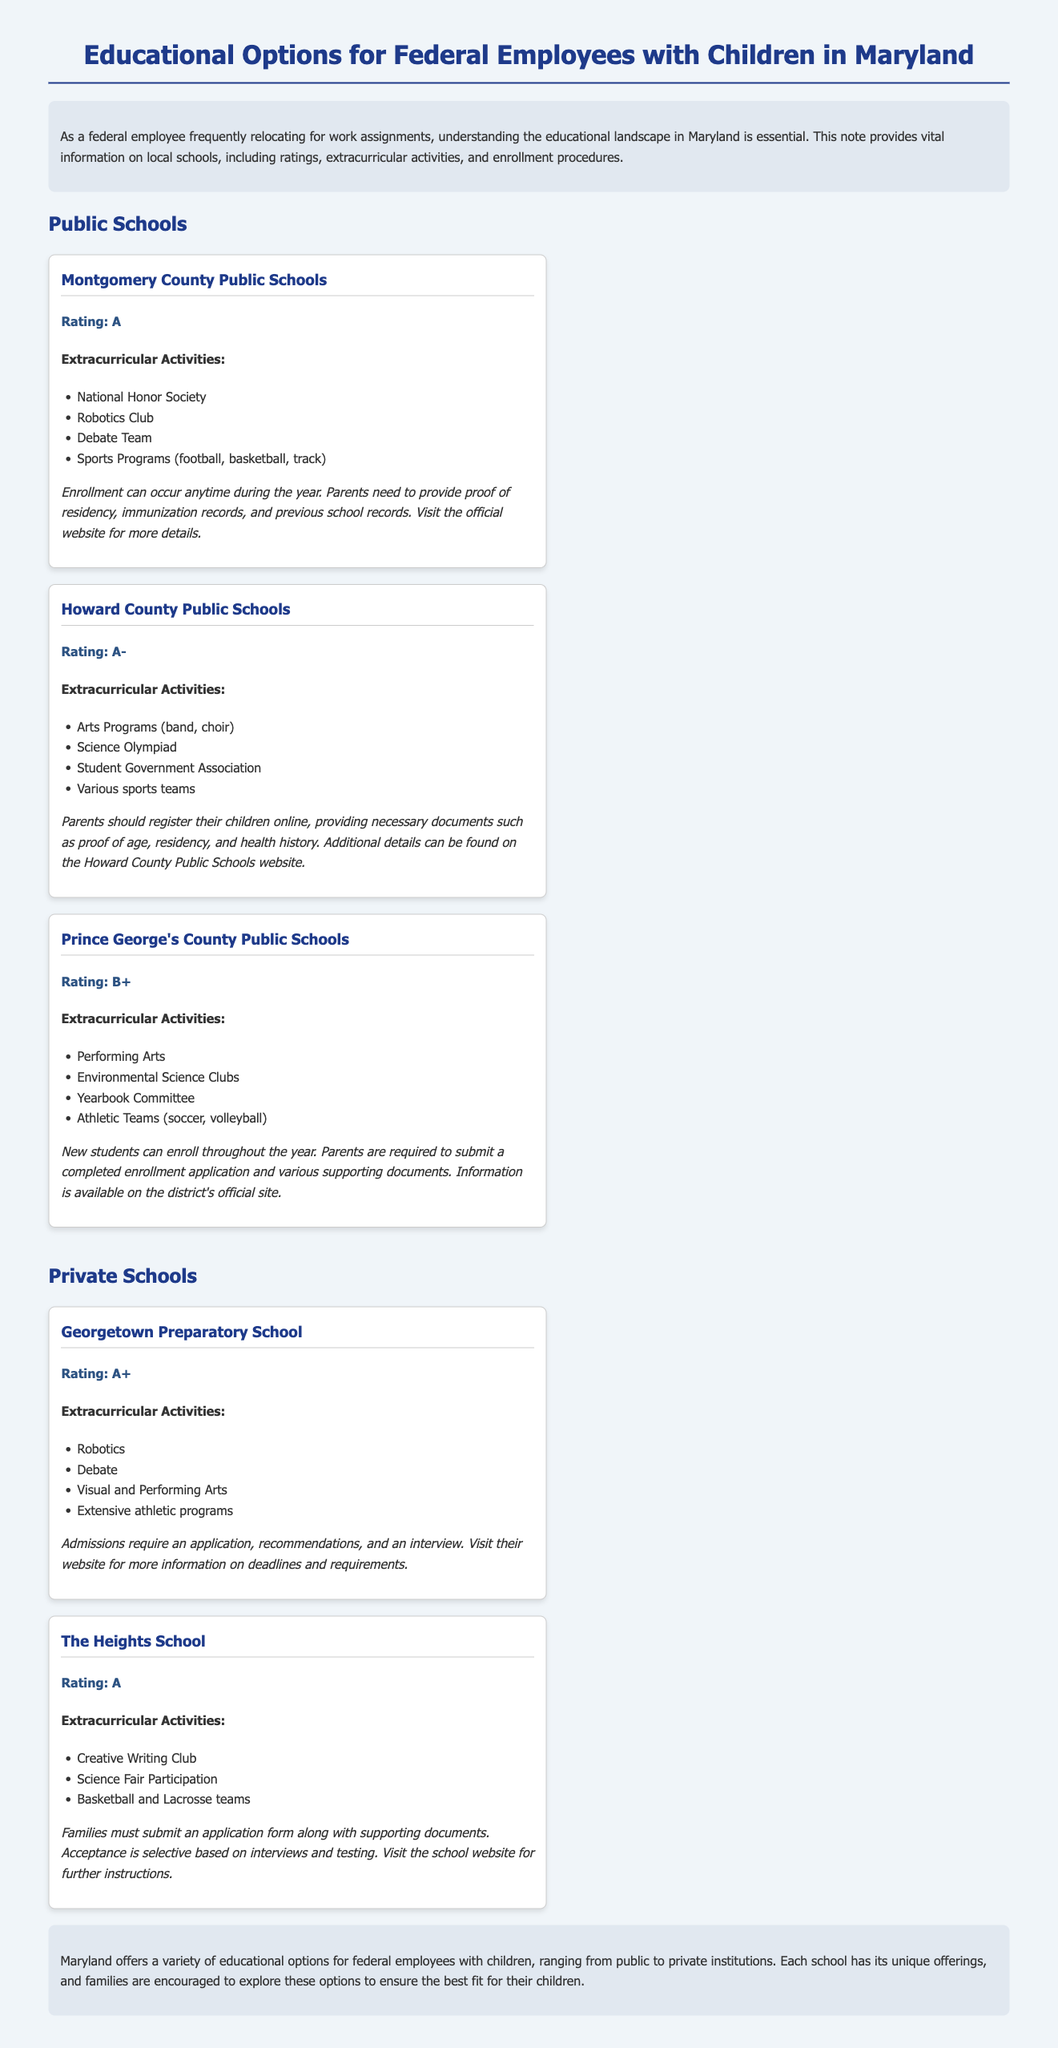What is the rating of Montgomery County Public Schools? The rating is stated directly in the document and is labeled as "Rating: A."
Answer: A What extracurricular activity is offered by Prince George's County Public Schools? The document lists various activities for each school, and one of them is "Performing Arts."
Answer: Performing Arts What is required for enrollment in Georgetown Preparatory School? The document specifies that admissions require "an application, recommendations, and an interview."
Answer: an application, recommendations, and an interview Which public school has the lowest rating? The ratings are compared in the document, and Prince George's County Public Schools has the lowest rating with "Rating: B+."
Answer: B+ How should parents register their children in Howard County Public Schools? The document provides information about the registration process, stating that parents should register online providing necessary documents.
Answer: Online registration What type of teams does The Heights School have? The document mentions specific extracurricular offerings for each school, and for The Heights School, it includes "Basketball and Lacrosse teams."
Answer: Basketball and Lacrosse teams Which public school offers a Robotics Club? The document lists extracurricular activities for each school, and it indicates that Montgomery County Public Schools offers a Robotics Club.
Answer: Montgomery County Public Schools What is an extracurricular activity associated with The Heights School? The document mentions that The Heights School offers "Creative Writing Club" as an extracurricular activity.
Answer: Creative Writing Club What are the documents needed for enrollment in Prince George's County Public Schools? The document states that parents must submit "a completed enrollment application and various supporting documents."
Answer: completed enrollment application and various supporting documents 